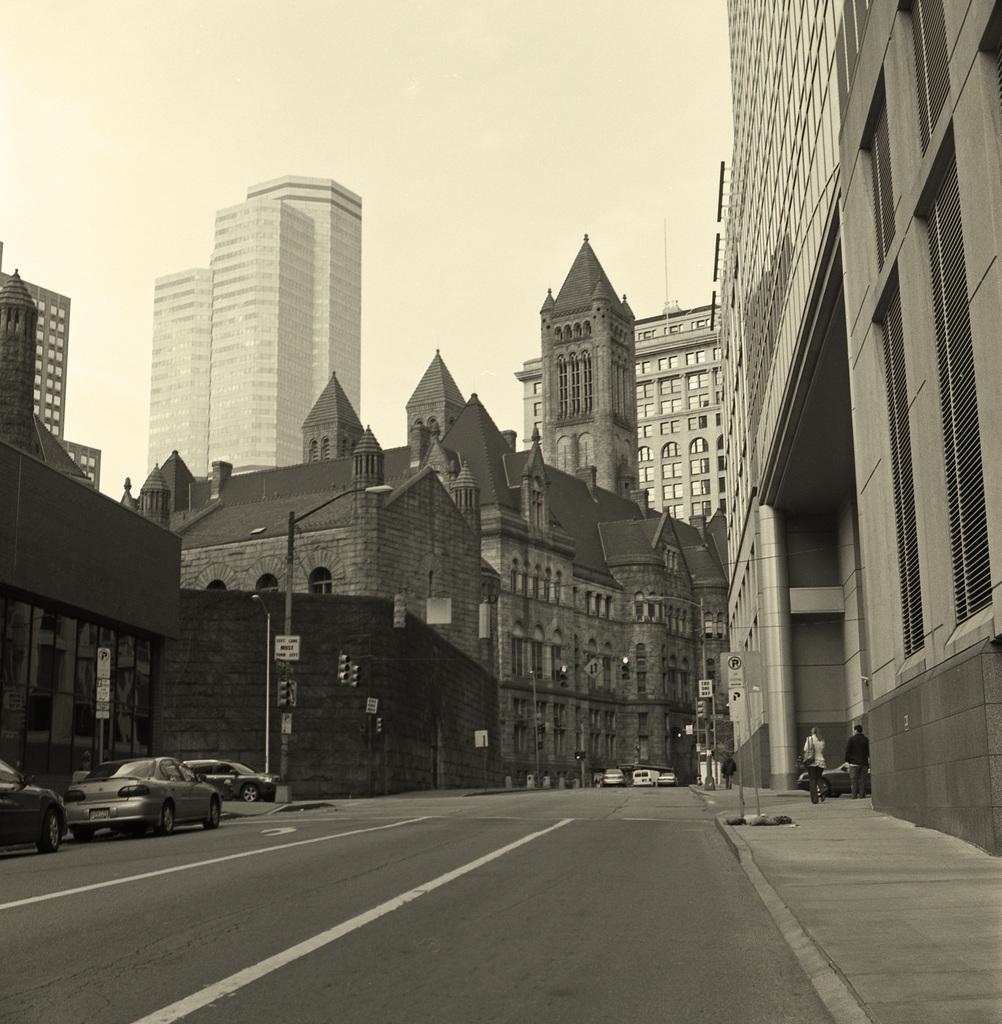Describe this image in one or two sentences. In this picture we can see vehicles on the road, three people on a footpath, traffic signals, sign boards, poles with lights, buildings with windows and some objects and in the background we can see the sky. 